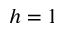<formula> <loc_0><loc_0><loc_500><loc_500>h = 1</formula> 